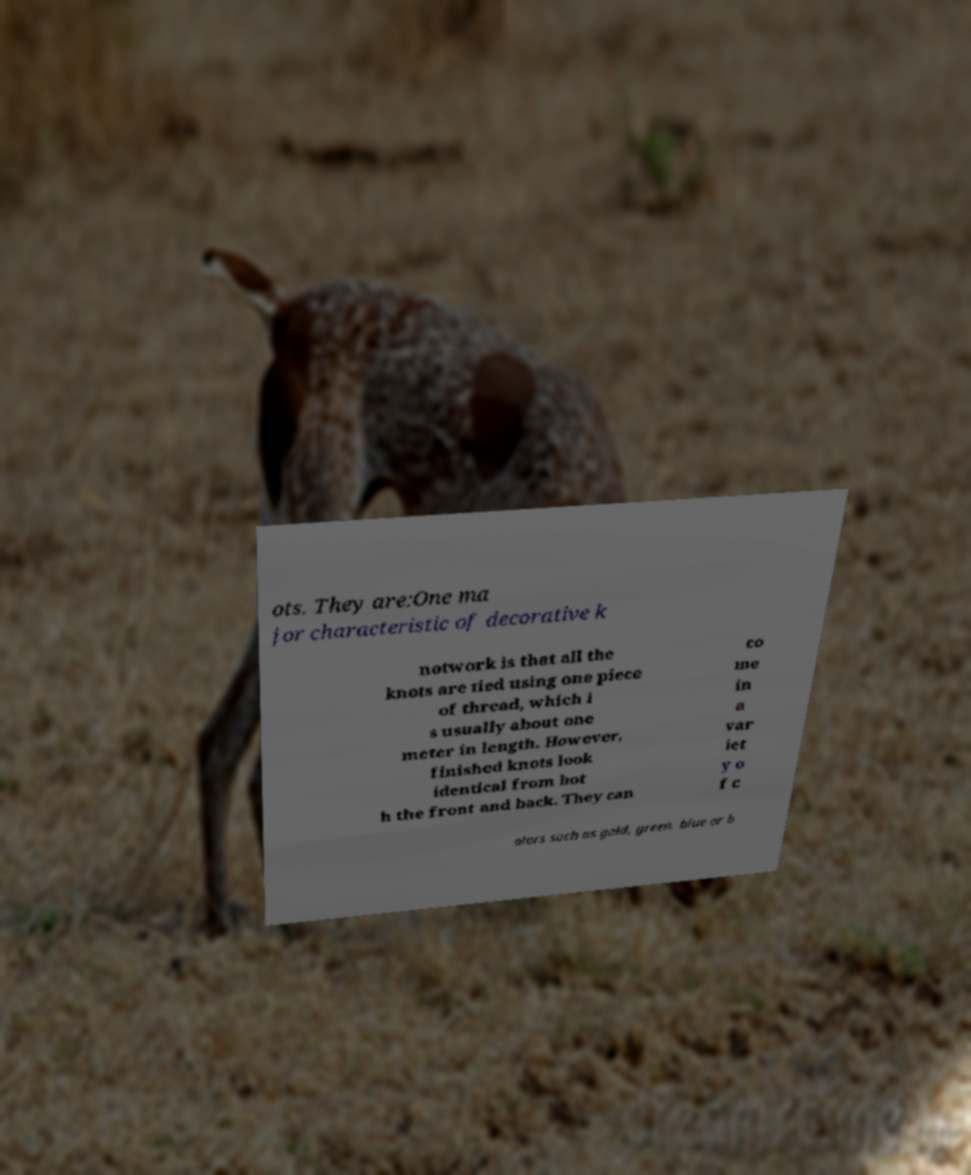I need the written content from this picture converted into text. Can you do that? ots. They are:One ma jor characteristic of decorative k notwork is that all the knots are tied using one piece of thread, which i s usually about one meter in length. However, finished knots look identical from bot h the front and back. They can co me in a var iet y o f c olors such as gold, green, blue or b 